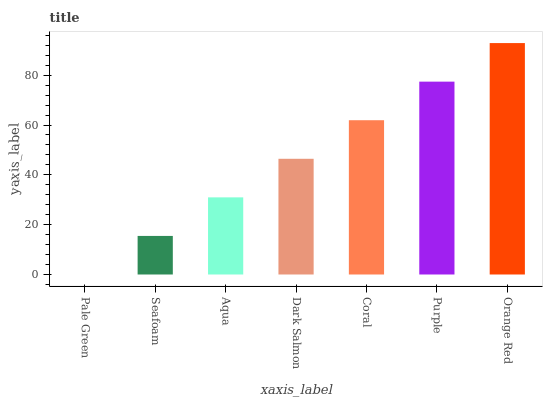Is Pale Green the minimum?
Answer yes or no. Yes. Is Orange Red the maximum?
Answer yes or no. Yes. Is Seafoam the minimum?
Answer yes or no. No. Is Seafoam the maximum?
Answer yes or no. No. Is Seafoam greater than Pale Green?
Answer yes or no. Yes. Is Pale Green less than Seafoam?
Answer yes or no. Yes. Is Pale Green greater than Seafoam?
Answer yes or no. No. Is Seafoam less than Pale Green?
Answer yes or no. No. Is Dark Salmon the high median?
Answer yes or no. Yes. Is Dark Salmon the low median?
Answer yes or no. Yes. Is Orange Red the high median?
Answer yes or no. No. Is Aqua the low median?
Answer yes or no. No. 